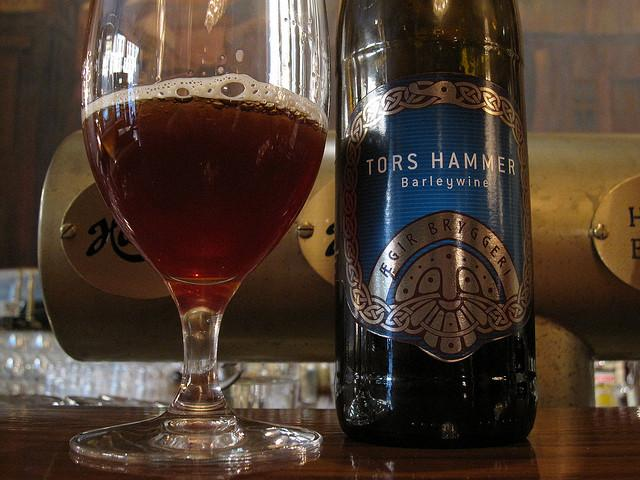The bottle is related to what group of people? Please explain your reasoning. vikings. The bottle's label makes reference to tors hammer. thor was a hammer wielding god who ruled in norse mythology and one of the options are people from the scandinavian region. 